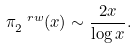Convert formula to latex. <formula><loc_0><loc_0><loc_500><loc_500>\pi ^ { \ r w } _ { 2 } ( x ) \sim \frac { 2 x } { \log x } .</formula> 